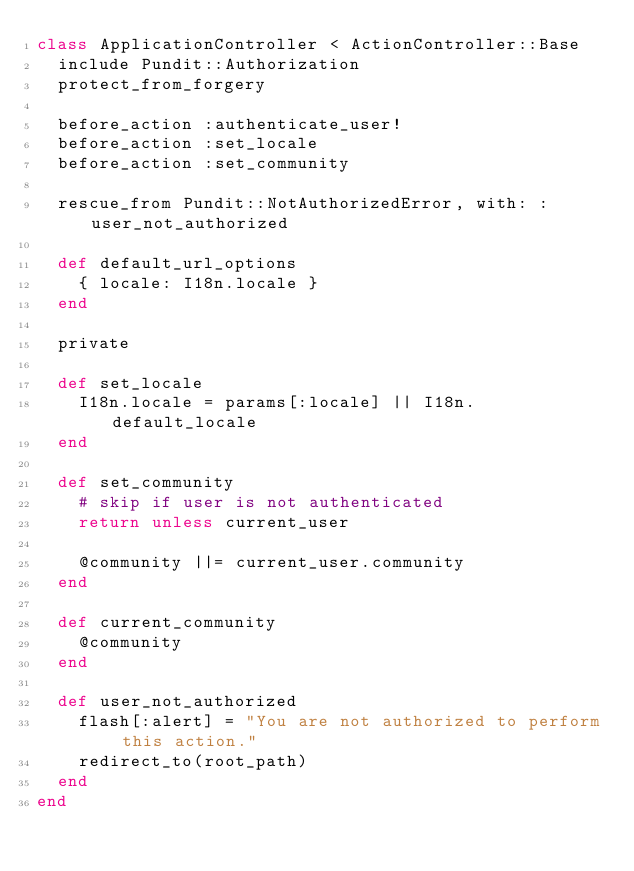Convert code to text. <code><loc_0><loc_0><loc_500><loc_500><_Ruby_>class ApplicationController < ActionController::Base
  include Pundit::Authorization
  protect_from_forgery

  before_action :authenticate_user!
  before_action :set_locale
  before_action :set_community

  rescue_from Pundit::NotAuthorizedError, with: :user_not_authorized

  def default_url_options
    { locale: I18n.locale }
  end

  private

  def set_locale
    I18n.locale = params[:locale] || I18n.default_locale
  end

  def set_community
    # skip if user is not authenticated
    return unless current_user

    @community ||= current_user.community
  end

  def current_community
    @community
  end

  def user_not_authorized
    flash[:alert] = "You are not authorized to perform this action."
    redirect_to(root_path)
  end
end
</code> 